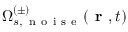<formula> <loc_0><loc_0><loc_500><loc_500>\Omega _ { s , \, n o i s e } ^ { ( \pm ) } ( r , t )</formula> 